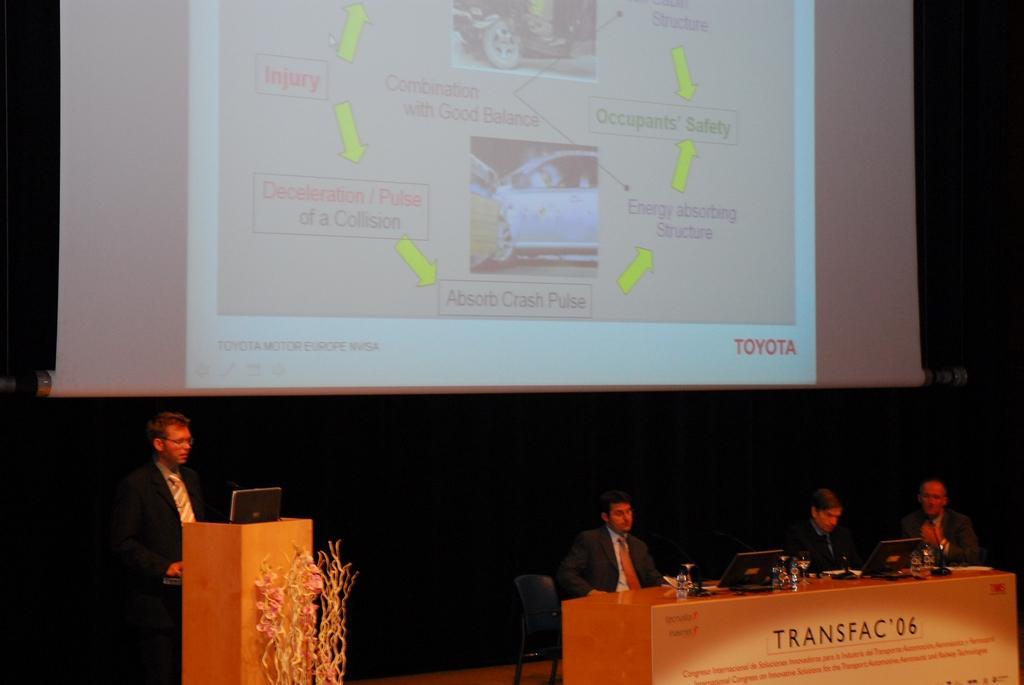How would you summarize this image in a sentence or two? In this image a man is standing behind a podium. On the podium there is a laptop. There are three people sitting on chair. In front of them on table there are bottles, screens , mics. In the background there is a screen. Here there are plants. 